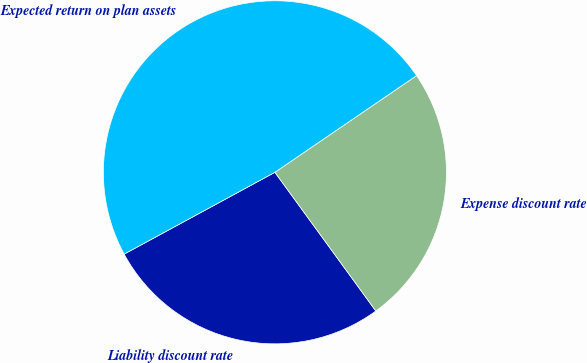Convert chart. <chart><loc_0><loc_0><loc_500><loc_500><pie_chart><fcel>Liability discount rate<fcel>Expense discount rate<fcel>Expected return on plan assets<nl><fcel>27.1%<fcel>24.52%<fcel>48.39%<nl></chart> 